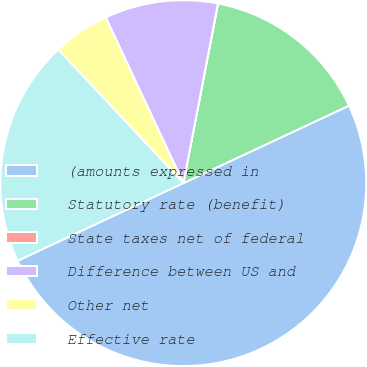Convert chart to OTSL. <chart><loc_0><loc_0><loc_500><loc_500><pie_chart><fcel>(amounts expressed in<fcel>Statutory rate (benefit)<fcel>State taxes net of federal<fcel>Difference between US and<fcel>Other net<fcel>Effective rate<nl><fcel>49.99%<fcel>15.0%<fcel>0.01%<fcel>10.0%<fcel>5.01%<fcel>20.0%<nl></chart> 